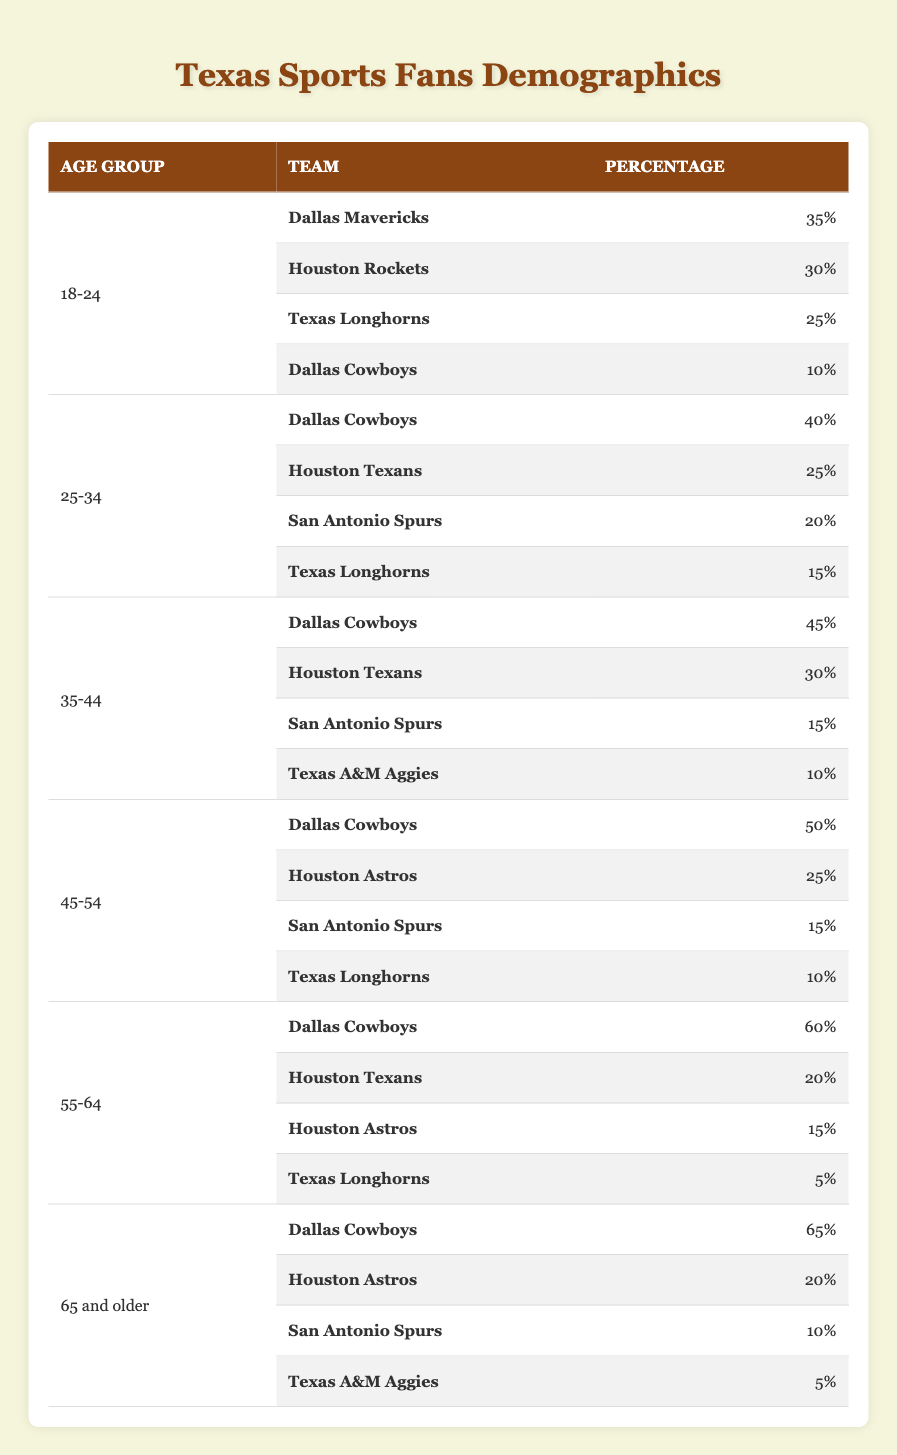What percentage of 18-24-year-olds prefer the Dallas Mavericks? The table shows that 35% of sports fans aged 18-24 prefer the Dallas Mavericks, as listed under the "18-24" age group.
Answer: 35% Which age group has the highest percentage of Dallas Cowboys fans? By examining the percentages for the Dallas Cowboys across all age groups in the table, the 65 and older age group has the highest percentage at 65%.
Answer: 65 and older What is the combined percentage of Houston Texans fans among the 25-34 and 35-44 age groups? For the 25-34 age group, 25% are Houston Texans fans, and for the 35-44 age group, 30% are fans. Combining these gives 25% + 30% = 55%.
Answer: 55% Do more people aged 45-54 prefer the Dallas Cowboys or the Houston Astros? The table indicates that 50% of the 45-54 age group prefer the Dallas Cowboys, while only 25% prefer the Houston Astros. Since 50% is greater than 25%, more prefer the Cowboys.
Answer: Yes What is the average percentage of Texas Longhorns fans across all age groups? The percentages for Texas Longhorns across all age groups are: 25%, 15%, 10%, 5%, and 0% (age groups 18-24, 25-34, 45-54, 55-64, and 65 and older, respectively). Adding these gives 25 + 15 + 10 + 5 + 0 = 55%. Dividing this sum by 5 gives an average of 55% / 5 = 11%.
Answer: 11% Which team is the second most popular among the 55-64 age group? In the 55-64 age group, the Dallas Cowboys have 60%, followed by the Houston Texans with 20%, so the Houston Texans are the second most popular team.
Answer: Houston Texans How many percentage points does the preference for the San Antonio Spurs decline from the 25-34 age group to the 45-54 age group? The San Antonio Spurs percentage in the 25-34 age group is 20%, and in the 45-54 age group, it is 15%. The decline is calculated as 20% - 15% = 5 percentage points.
Answer: 5 percentage points Which team has the lowest percentage among fans aged 65 and older? The table shows that the Texas A&M Aggies have 5%, which is lower than the percentages for the other teams in the 65 and older age group.
Answer: Texas A&M Aggies 